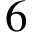Convert formula to latex. <formula><loc_0><loc_0><loc_500><loc_500>6</formula> 